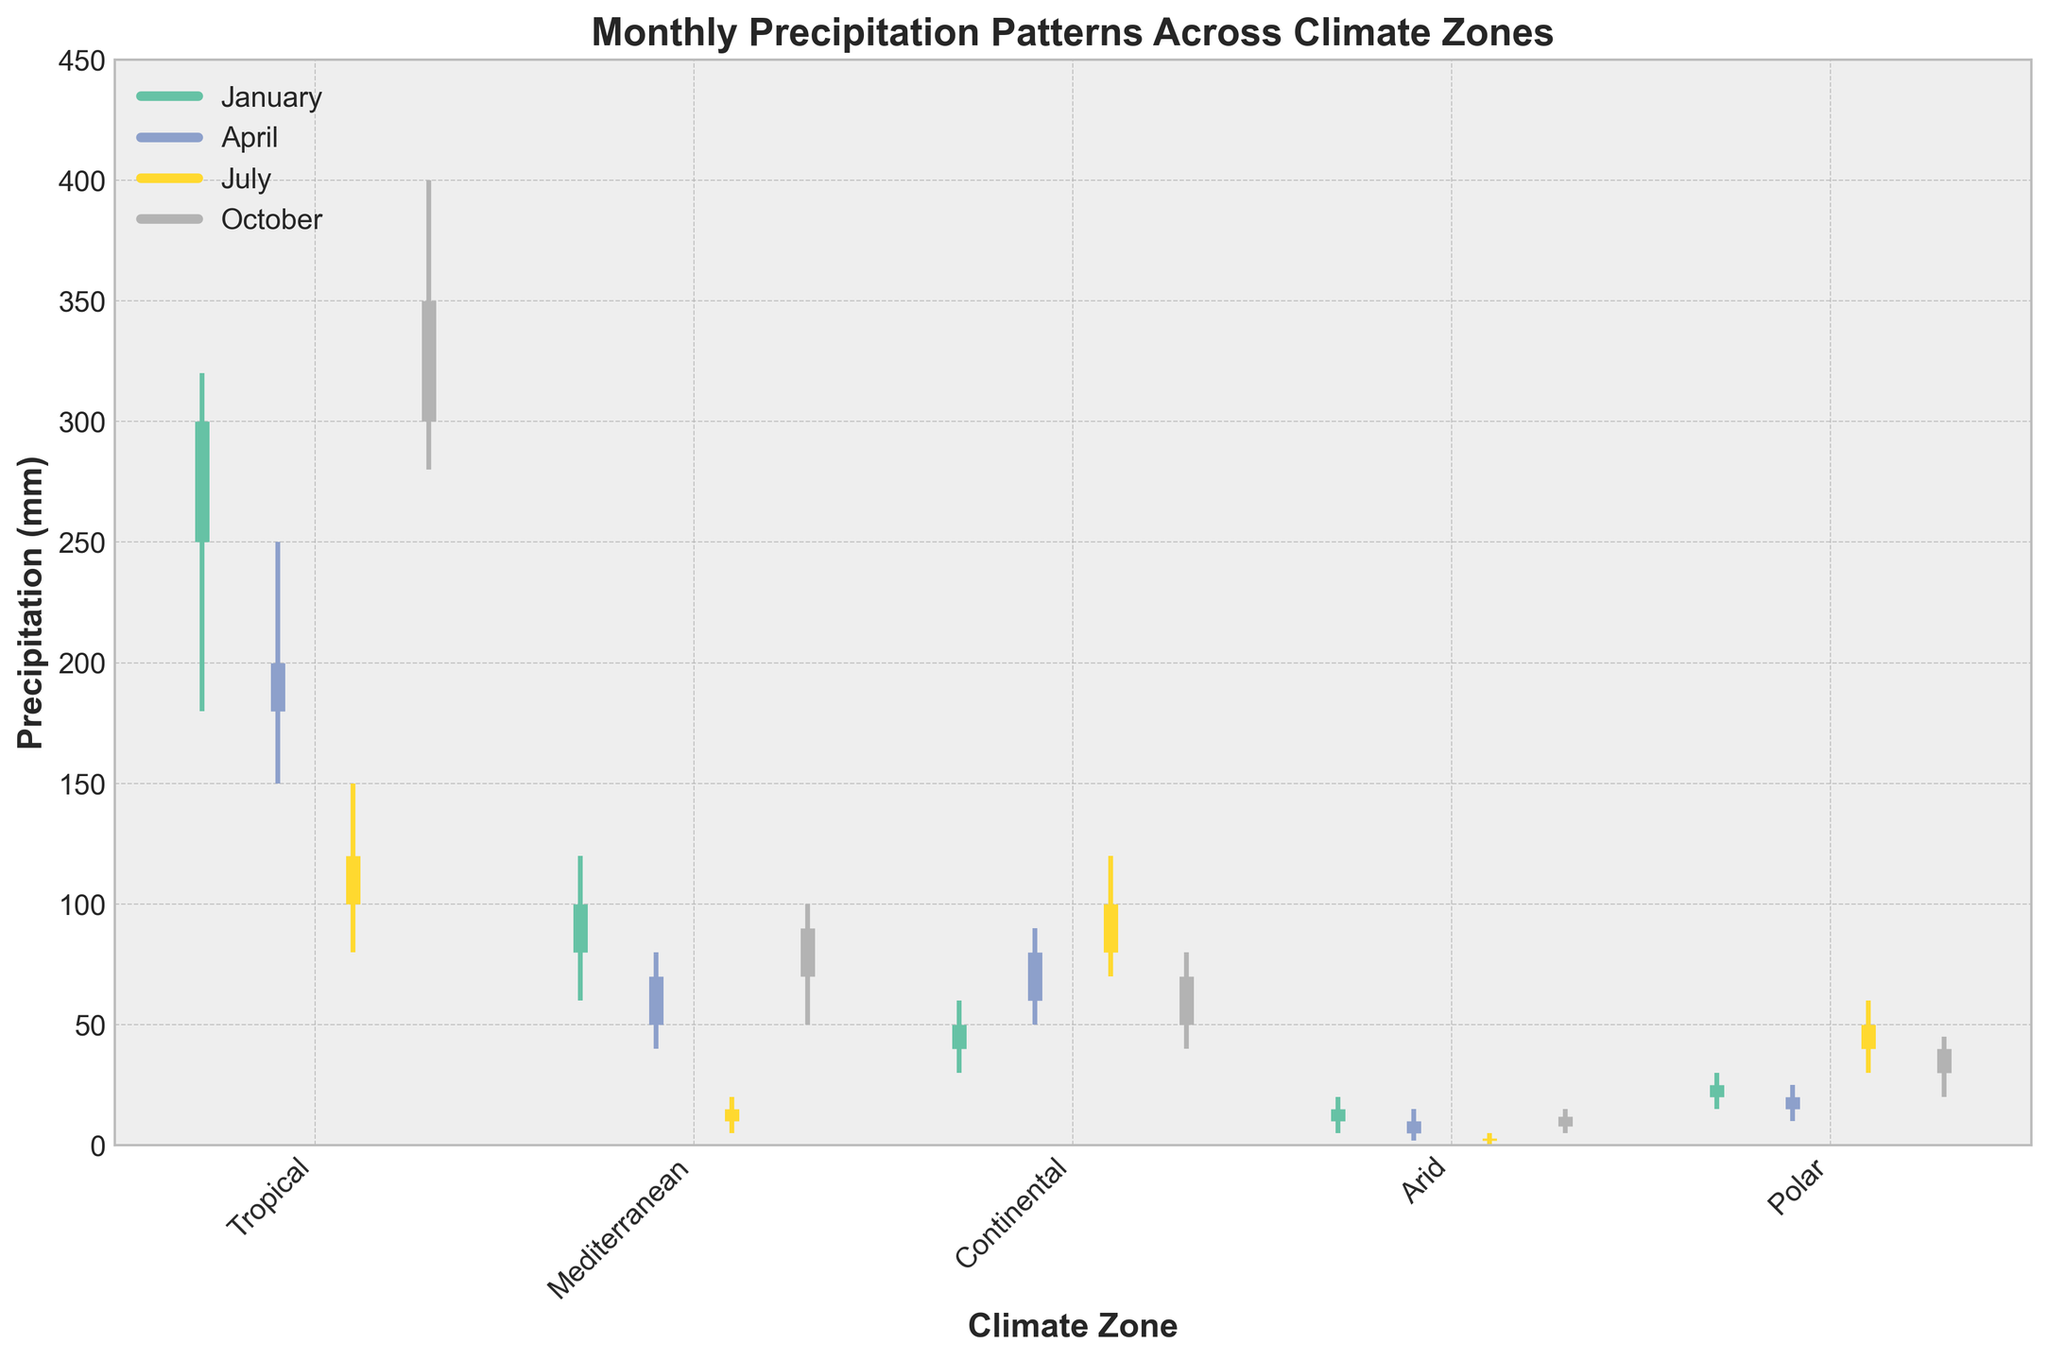Which climate zone has the highest precipitation in January? To find the climate zone with the highest precipitation in January, look at the highest values for January. The Tropical zone has the highest value with 320 mm.
Answer: Tropical What is the range of precipitation in the Continental zone in April? The range is calculated from the highest to the lowest value in April for the Continental zone. The high is 90 mm and the low is 50 mm. The range is 90 - 50 = 40 mm.
Answer: 40 mm Which month has the lowest precipitation in the Arid zone? Examine all the months for the Arid zone and compare their lowest values. July has the lowest value of 0 mm.
Answer: July In which month does the Tropical zone experience the greatest range in precipitation values? Calculate the range for each month in the Tropical zone. January (320 - 180 = 140 mm), April (250 - 150 = 100 mm), July (150 - 80 = 70 mm), October (400 - 280 = 120 mm). January has the greatest range of 140 mm.
Answer: January Compare the high precipitation values in July across all climate zones. Which zone receives the highest precipitation? Look at the high values for July in each zone. Tropical (150 mm), Mediterranean (20 mm), Continental (120 mm), Arid (5 mm), Polar (60 mm). The Tropical zone has the highest value of 150 mm.
Answer: Tropical What is the average high precipitation in October for the Polar and Continental zones combined? Find the high values for October in both zones: Polar (45 mm) and Continental (80 mm). Average = (45 + 80) / 2 = 62.5 mm.
Answer: 62.5 mm How does the low precipitation in April for the Mediterranean zone compare to that in January for the Arid zone? Look at the low values for April in Mediterranean (40 mm) and January in Arid (5 mm). 40 mm is greater than 5 mm.
Answer: Mediterranean April > Arid January What month shows the minimum high precipitation in the Mediterranean zone? Compare the high values for all months in the Mediterranean zone. January (120 mm), April (80 mm), July (20 mm), October (100 mm). July has the minimum high value of 20 mm.
Answer: July Which climate zone has the most uniformly distributed precipitation throughout the year? Check the consistency of the high and low values across all months for each zone. The Mediterranean zone has relatively consistent values: January (120-60), April (80-40), July (20-5), October (100-50). The variations are relatively small compared to other zones.
Answer: Mediterranean 